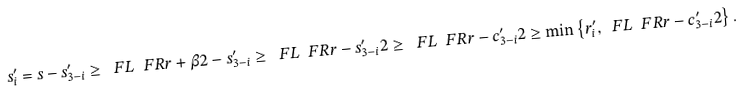Convert formula to latex. <formula><loc_0><loc_0><loc_500><loc_500>s ^ { \prime } _ { i } = s - s ^ { \prime } _ { 3 - i } \geq \ F L { \ F R { r + \beta } 2 } - s ^ { \prime } _ { 3 - i } \geq \ F L { \ F R { r - s ^ { \prime } _ { 3 - i } } 2 } \geq \ F L { \ F R { r - c ^ { \prime } _ { 3 - i } } 2 } \geq \min \left \{ r ^ { \prime } _ { i } , \ F L { \ F R { r - c ^ { \prime } _ { 3 - i } } 2 } \right \} .</formula> 